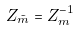<formula> <loc_0><loc_0><loc_500><loc_500>Z _ { \tilde { m } } = Z _ { m } ^ { - 1 }</formula> 